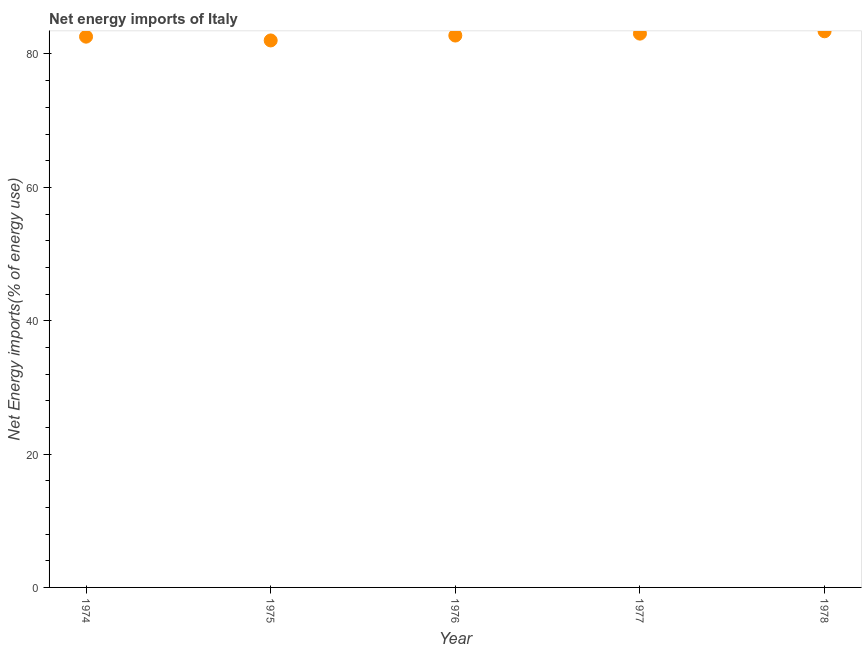What is the energy imports in 1976?
Provide a succinct answer. 82.77. Across all years, what is the maximum energy imports?
Offer a terse response. 83.41. Across all years, what is the minimum energy imports?
Keep it short and to the point. 82.03. In which year was the energy imports maximum?
Give a very brief answer. 1978. In which year was the energy imports minimum?
Your answer should be compact. 1975. What is the sum of the energy imports?
Provide a succinct answer. 413.86. What is the difference between the energy imports in 1975 and 1978?
Keep it short and to the point. -1.37. What is the average energy imports per year?
Offer a very short reply. 82.77. What is the median energy imports?
Your response must be concise. 82.77. What is the ratio of the energy imports in 1975 to that in 1976?
Offer a terse response. 0.99. Is the difference between the energy imports in 1975 and 1977 greater than the difference between any two years?
Your answer should be very brief. No. What is the difference between the highest and the second highest energy imports?
Give a very brief answer. 0.35. What is the difference between the highest and the lowest energy imports?
Your answer should be very brief. 1.37. In how many years, is the energy imports greater than the average energy imports taken over all years?
Ensure brevity in your answer.  2. What is the difference between two consecutive major ticks on the Y-axis?
Provide a short and direct response. 20. Are the values on the major ticks of Y-axis written in scientific E-notation?
Your answer should be very brief. No. Does the graph contain grids?
Offer a very short reply. No. What is the title of the graph?
Provide a succinct answer. Net energy imports of Italy. What is the label or title of the X-axis?
Give a very brief answer. Year. What is the label or title of the Y-axis?
Keep it short and to the point. Net Energy imports(% of energy use). What is the Net Energy imports(% of energy use) in 1974?
Provide a succinct answer. 82.6. What is the Net Energy imports(% of energy use) in 1975?
Offer a terse response. 82.03. What is the Net Energy imports(% of energy use) in 1976?
Offer a terse response. 82.77. What is the Net Energy imports(% of energy use) in 1977?
Ensure brevity in your answer.  83.05. What is the Net Energy imports(% of energy use) in 1978?
Ensure brevity in your answer.  83.41. What is the difference between the Net Energy imports(% of energy use) in 1974 and 1975?
Your answer should be very brief. 0.57. What is the difference between the Net Energy imports(% of energy use) in 1974 and 1976?
Make the answer very short. -0.17. What is the difference between the Net Energy imports(% of energy use) in 1974 and 1977?
Keep it short and to the point. -0.45. What is the difference between the Net Energy imports(% of energy use) in 1974 and 1978?
Offer a terse response. -0.81. What is the difference between the Net Energy imports(% of energy use) in 1975 and 1976?
Your response must be concise. -0.73. What is the difference between the Net Energy imports(% of energy use) in 1975 and 1977?
Offer a terse response. -1.02. What is the difference between the Net Energy imports(% of energy use) in 1975 and 1978?
Offer a terse response. -1.37. What is the difference between the Net Energy imports(% of energy use) in 1976 and 1977?
Provide a short and direct response. -0.29. What is the difference between the Net Energy imports(% of energy use) in 1976 and 1978?
Your response must be concise. -0.64. What is the difference between the Net Energy imports(% of energy use) in 1977 and 1978?
Give a very brief answer. -0.35. What is the ratio of the Net Energy imports(% of energy use) in 1974 to that in 1975?
Your answer should be compact. 1.01. What is the ratio of the Net Energy imports(% of energy use) in 1974 to that in 1976?
Your answer should be very brief. 1. What is the ratio of the Net Energy imports(% of energy use) in 1974 to that in 1978?
Ensure brevity in your answer.  0.99. What is the ratio of the Net Energy imports(% of energy use) in 1975 to that in 1976?
Your answer should be very brief. 0.99. What is the ratio of the Net Energy imports(% of energy use) in 1975 to that in 1977?
Your answer should be compact. 0.99. What is the ratio of the Net Energy imports(% of energy use) in 1975 to that in 1978?
Ensure brevity in your answer.  0.98. What is the ratio of the Net Energy imports(% of energy use) in 1976 to that in 1977?
Give a very brief answer. 1. What is the ratio of the Net Energy imports(% of energy use) in 1976 to that in 1978?
Your answer should be compact. 0.99. 